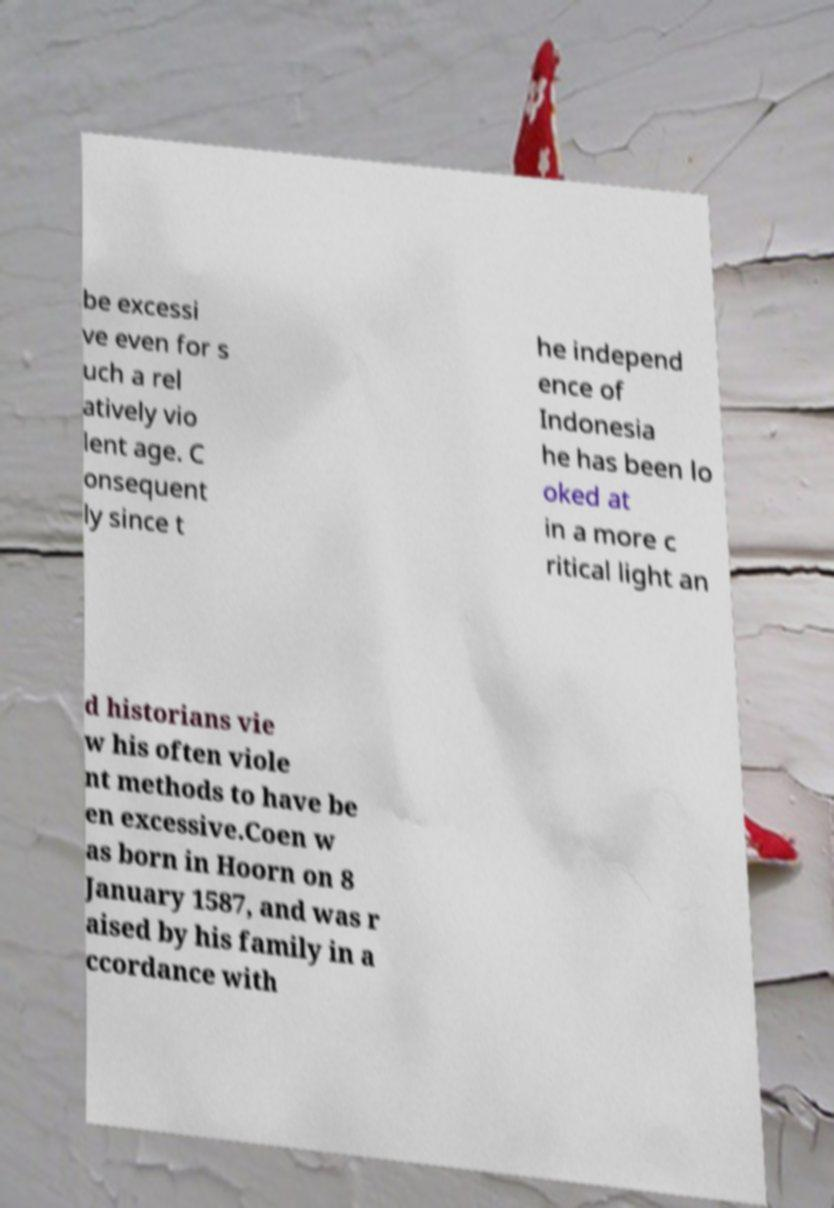I need the written content from this picture converted into text. Can you do that? be excessi ve even for s uch a rel atively vio lent age. C onsequent ly since t he independ ence of Indonesia he has been lo oked at in a more c ritical light an d historians vie w his often viole nt methods to have be en excessive.Coen w as born in Hoorn on 8 January 1587, and was r aised by his family in a ccordance with 